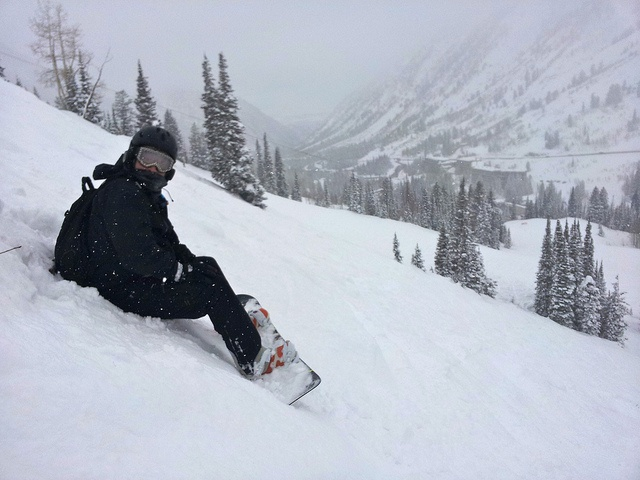Describe the objects in this image and their specific colors. I can see people in darkgray, black, gray, and lavender tones, backpack in darkgray, black, gray, and lavender tones, and snowboard in darkgray and lightgray tones in this image. 